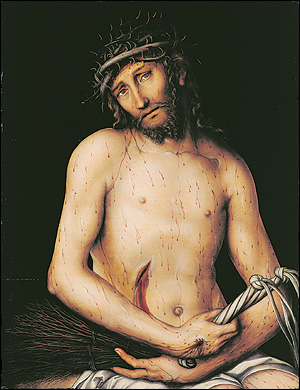How does the artist manipulate color to convey mood in this painting? The artist predominantly uses a palette of dark, muted colors that contribute to the painting's heavy, somber mood. The stark contrast of Christ's pale skin against the dark background not only focuses attention on him as the subject but also enhances the portrayal of pain and suffering. This careful manipulation of color not only deepens the visual impact but also evokes a sense of solemnity and introspection, fitting for the religious theme of the artwork. 